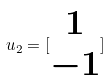<formula> <loc_0><loc_0><loc_500><loc_500>u _ { 2 } = [ \begin{matrix} 1 \\ - 1 \end{matrix} ]</formula> 